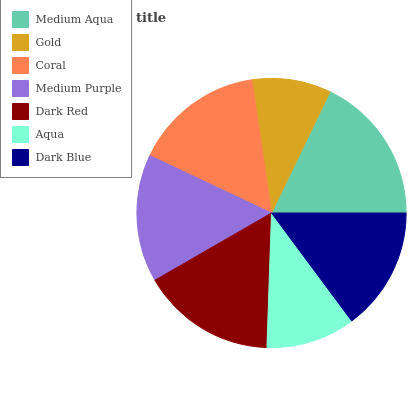Is Gold the minimum?
Answer yes or no. Yes. Is Medium Aqua the maximum?
Answer yes or no. Yes. Is Coral the minimum?
Answer yes or no. No. Is Coral the maximum?
Answer yes or no. No. Is Coral greater than Gold?
Answer yes or no. Yes. Is Gold less than Coral?
Answer yes or no. Yes. Is Gold greater than Coral?
Answer yes or no. No. Is Coral less than Gold?
Answer yes or no. No. Is Medium Purple the high median?
Answer yes or no. Yes. Is Medium Purple the low median?
Answer yes or no. Yes. Is Medium Aqua the high median?
Answer yes or no. No. Is Aqua the low median?
Answer yes or no. No. 